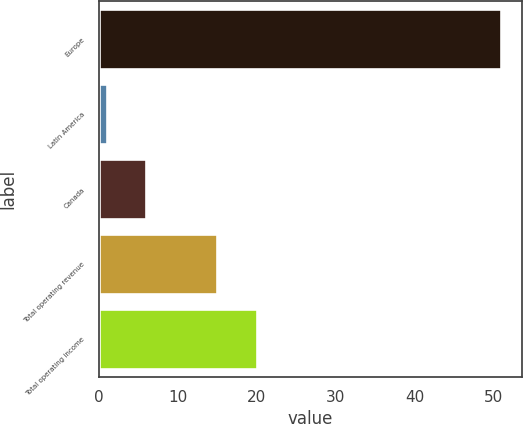<chart> <loc_0><loc_0><loc_500><loc_500><bar_chart><fcel>Europe<fcel>Latin America<fcel>Canada<fcel>Total operating revenue<fcel>Total operating income<nl><fcel>51<fcel>1<fcel>6<fcel>15<fcel>20<nl></chart> 